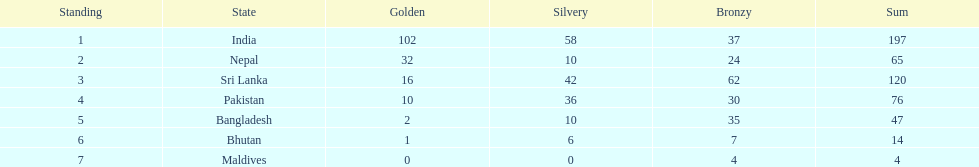Name a country listed in the table, other than india? Nepal. I'm looking to parse the entire table for insights. Could you assist me with that? {'header': ['Standing', 'State', 'Golden', 'Silvery', 'Bronzy', 'Sum'], 'rows': [['1', 'India', '102', '58', '37', '197'], ['2', 'Nepal', '32', '10', '24', '65'], ['3', 'Sri Lanka', '16', '42', '62', '120'], ['4', 'Pakistan', '10', '36', '30', '76'], ['5', 'Bangladesh', '2', '10', '35', '47'], ['6', 'Bhutan', '1', '6', '7', '14'], ['7', 'Maldives', '0', '0', '4', '4']]} 